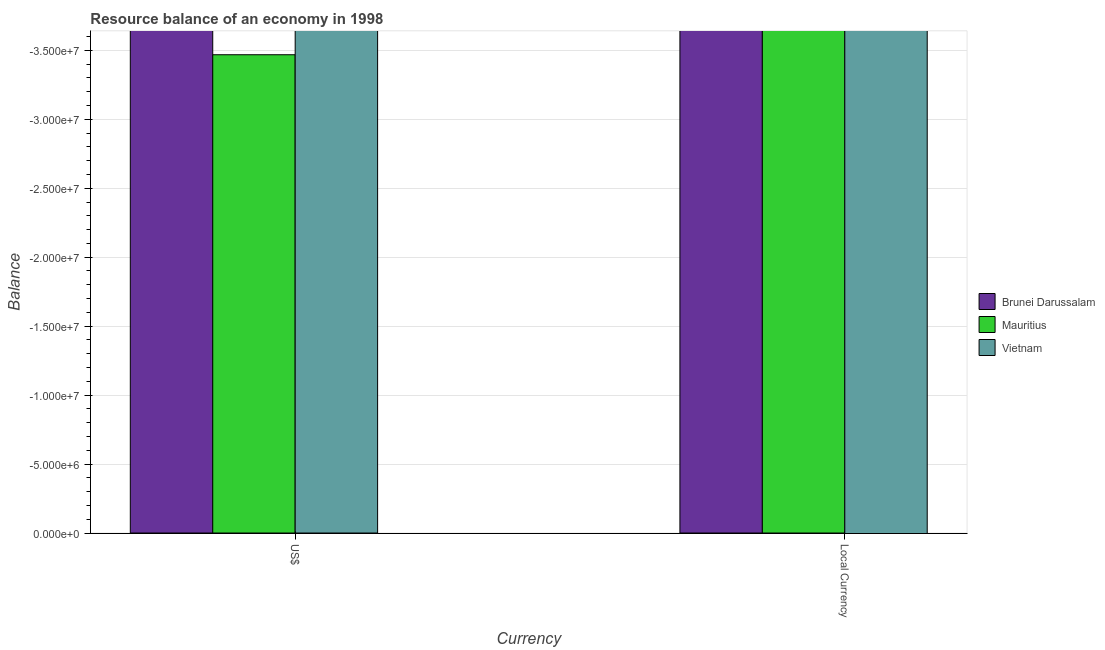Are the number of bars per tick equal to the number of legend labels?
Your answer should be very brief. No. Are the number of bars on each tick of the X-axis equal?
Provide a succinct answer. Yes. How many bars are there on the 2nd tick from the left?
Ensure brevity in your answer.  0. How many bars are there on the 1st tick from the right?
Make the answer very short. 0. What is the label of the 2nd group of bars from the left?
Your answer should be compact. Local Currency. What is the total resource balance in constant us$ in the graph?
Offer a terse response. 0. What is the difference between the resource balance in us$ in Brunei Darussalam and the resource balance in constant us$ in Vietnam?
Your answer should be compact. 0. In how many countries, is the resource balance in constant us$ greater than -29000000 units?
Offer a very short reply. 0. In how many countries, is the resource balance in us$ greater than the average resource balance in us$ taken over all countries?
Ensure brevity in your answer.  0. What is the difference between two consecutive major ticks on the Y-axis?
Provide a short and direct response. 5.00e+06. Does the graph contain grids?
Provide a succinct answer. Yes. Where does the legend appear in the graph?
Your response must be concise. Center right. How are the legend labels stacked?
Keep it short and to the point. Vertical. What is the title of the graph?
Give a very brief answer. Resource balance of an economy in 1998. Does "Kenya" appear as one of the legend labels in the graph?
Offer a terse response. No. What is the label or title of the X-axis?
Offer a very short reply. Currency. What is the label or title of the Y-axis?
Ensure brevity in your answer.  Balance. What is the Balance of Mauritius in US$?
Offer a terse response. 0. What is the Balance of Vietnam in US$?
Provide a short and direct response. 0. What is the average Balance of Mauritius per Currency?
Your answer should be very brief. 0. What is the average Balance in Vietnam per Currency?
Your response must be concise. 0. 